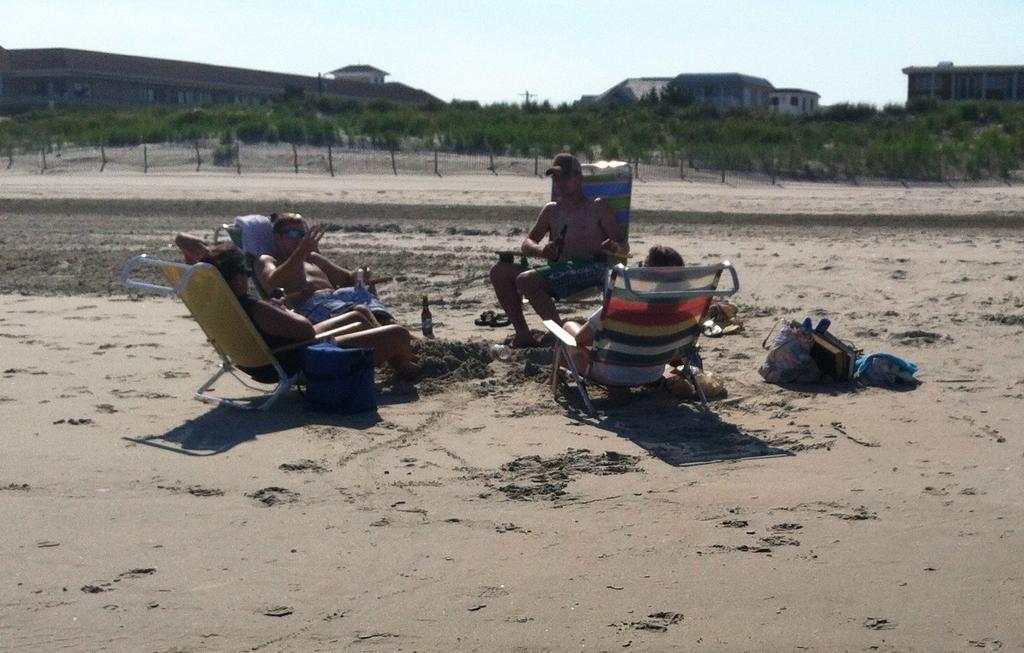In one or two sentences, can you explain what this image depicts? In this image we can see few persons sitting on chairs and a person is holding a bottle. Beside the persons we can see few objects on the ground. Behind the persons we can see the fencing, trees and buildings. At the top we can see the sky. 